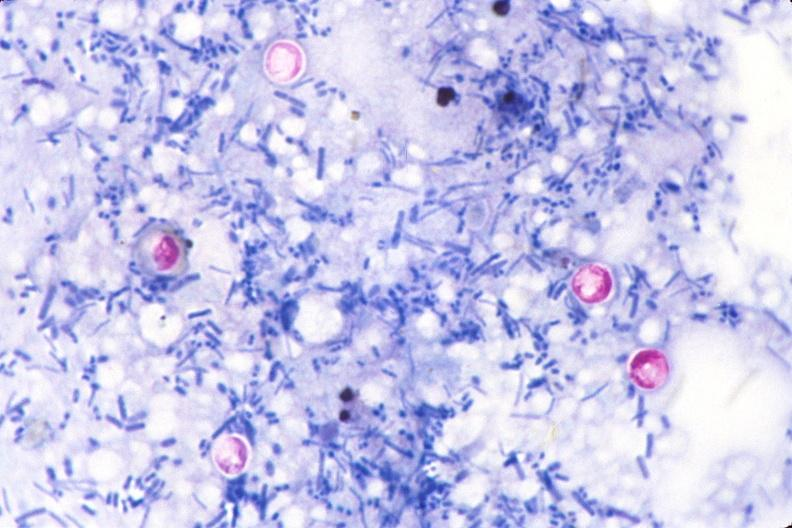what stain of feces?
Answer the question using a single word or phrase. Cryptosporidia 